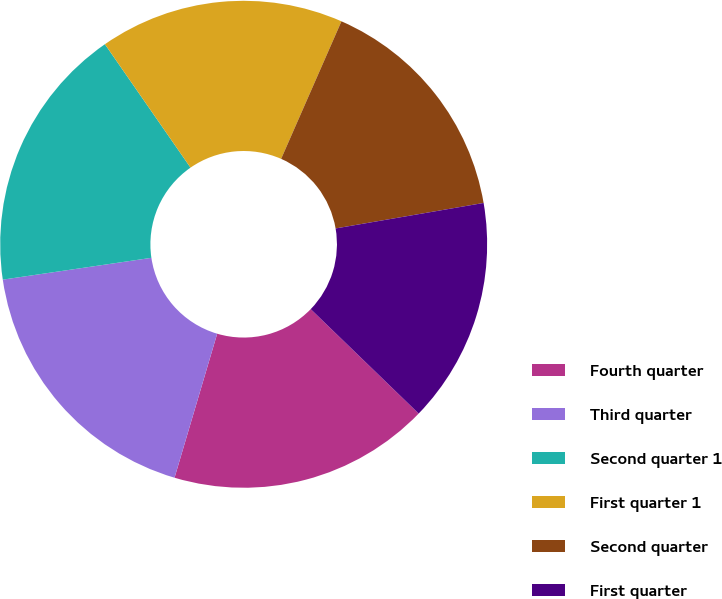Convert chart to OTSL. <chart><loc_0><loc_0><loc_500><loc_500><pie_chart><fcel>Fourth quarter<fcel>Third quarter<fcel>Second quarter 1<fcel>First quarter 1<fcel>Second quarter<fcel>First quarter<nl><fcel>17.35%<fcel>18.1%<fcel>17.67%<fcel>16.23%<fcel>15.71%<fcel>14.95%<nl></chart> 